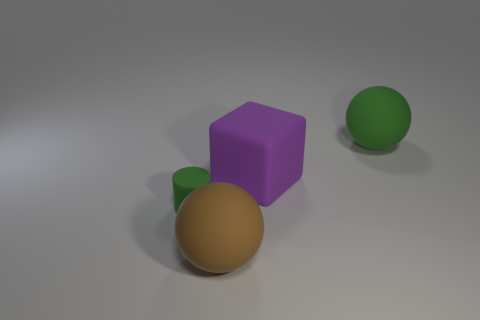Add 3 tiny purple cubes. How many objects exist? 7 Subtract all cubes. How many objects are left? 3 Add 3 big green matte balls. How many big green matte balls exist? 4 Subtract 0 purple spheres. How many objects are left? 4 Subtract all small metallic cubes. Subtract all green rubber objects. How many objects are left? 2 Add 1 blocks. How many blocks are left? 2 